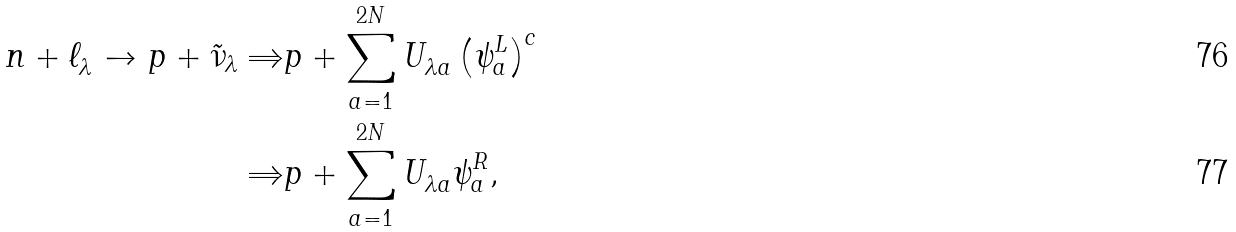<formula> <loc_0><loc_0><loc_500><loc_500>n + \ell _ { \lambda } ^ { } \to p + \tilde { \nu } _ { \lambda } \Rightarrow & p + \sum _ { a = 1 } ^ { 2 N } U _ { \lambda a } ^ { } \left ( \psi _ { a } ^ { L } \right ) ^ { c } \\ \Rightarrow & p + \sum _ { a = 1 } ^ { 2 N } U _ { \lambda a } ^ { } \psi _ { a } ^ { R } ,</formula> 